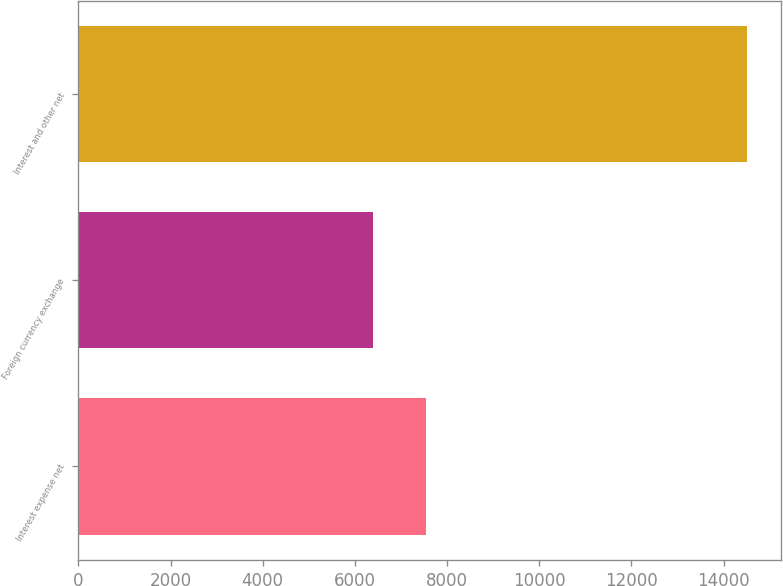Convert chart. <chart><loc_0><loc_0><loc_500><loc_500><bar_chart><fcel>Interest expense net<fcel>Foreign currency exchange<fcel>Interest and other net<nl><fcel>7539<fcel>6397<fcel>14515<nl></chart> 